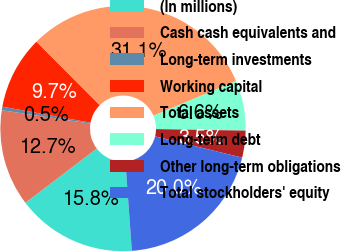<chart> <loc_0><loc_0><loc_500><loc_500><pie_chart><fcel>(In millions)<fcel>Cash cash equivalents and<fcel>Long-term investments<fcel>Working capital<fcel>Total assets<fcel>Long-term debt<fcel>Other long-term obligations<fcel>Total stockholders' equity<nl><fcel>15.8%<fcel>12.74%<fcel>0.47%<fcel>9.67%<fcel>31.14%<fcel>6.6%<fcel>3.54%<fcel>20.04%<nl></chart> 